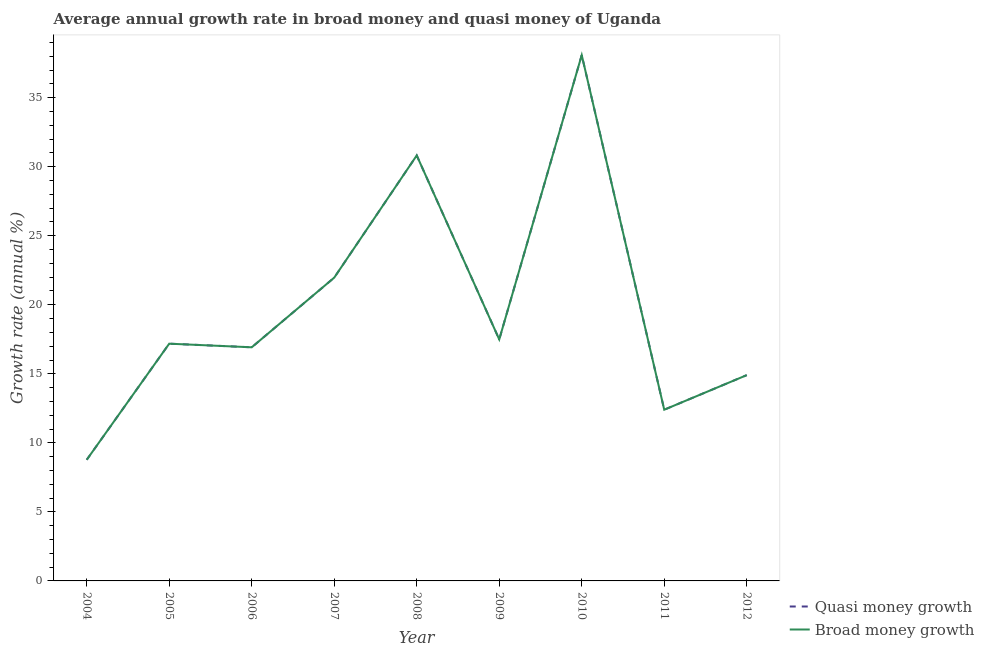How many different coloured lines are there?
Provide a short and direct response. 2. Is the number of lines equal to the number of legend labels?
Your response must be concise. Yes. What is the annual growth rate in quasi money in 2011?
Offer a very short reply. 12.4. Across all years, what is the maximum annual growth rate in broad money?
Give a very brief answer. 38.08. Across all years, what is the minimum annual growth rate in broad money?
Provide a succinct answer. 8.77. In which year was the annual growth rate in quasi money minimum?
Keep it short and to the point. 2004. What is the total annual growth rate in quasi money in the graph?
Keep it short and to the point. 178.54. What is the difference between the annual growth rate in broad money in 2005 and that in 2012?
Provide a short and direct response. 2.28. What is the difference between the annual growth rate in broad money in 2012 and the annual growth rate in quasi money in 2005?
Offer a very short reply. -2.28. What is the average annual growth rate in broad money per year?
Offer a terse response. 19.84. In the year 2007, what is the difference between the annual growth rate in broad money and annual growth rate in quasi money?
Offer a very short reply. 0. What is the ratio of the annual growth rate in broad money in 2006 to that in 2009?
Ensure brevity in your answer.  0.97. What is the difference between the highest and the second highest annual growth rate in broad money?
Your answer should be compact. 7.27. What is the difference between the highest and the lowest annual growth rate in quasi money?
Your answer should be very brief. 29.31. What is the difference between two consecutive major ticks on the Y-axis?
Ensure brevity in your answer.  5. Are the values on the major ticks of Y-axis written in scientific E-notation?
Provide a short and direct response. No. Does the graph contain grids?
Offer a very short reply. No. How many legend labels are there?
Offer a terse response. 2. What is the title of the graph?
Your response must be concise. Average annual growth rate in broad money and quasi money of Uganda. What is the label or title of the X-axis?
Offer a very short reply. Year. What is the label or title of the Y-axis?
Offer a terse response. Growth rate (annual %). What is the Growth rate (annual %) in Quasi money growth in 2004?
Offer a very short reply. 8.77. What is the Growth rate (annual %) in Broad money growth in 2004?
Your answer should be very brief. 8.77. What is the Growth rate (annual %) of Quasi money growth in 2005?
Offer a terse response. 17.18. What is the Growth rate (annual %) in Broad money growth in 2005?
Ensure brevity in your answer.  17.18. What is the Growth rate (annual %) in Quasi money growth in 2006?
Your answer should be compact. 16.92. What is the Growth rate (annual %) in Broad money growth in 2006?
Offer a very short reply. 16.92. What is the Growth rate (annual %) in Quasi money growth in 2007?
Give a very brief answer. 21.97. What is the Growth rate (annual %) in Broad money growth in 2007?
Offer a terse response. 21.97. What is the Growth rate (annual %) in Quasi money growth in 2008?
Provide a short and direct response. 30.82. What is the Growth rate (annual %) of Broad money growth in 2008?
Offer a terse response. 30.82. What is the Growth rate (annual %) in Quasi money growth in 2009?
Offer a terse response. 17.49. What is the Growth rate (annual %) of Broad money growth in 2009?
Your answer should be very brief. 17.49. What is the Growth rate (annual %) in Quasi money growth in 2010?
Ensure brevity in your answer.  38.08. What is the Growth rate (annual %) of Broad money growth in 2010?
Give a very brief answer. 38.08. What is the Growth rate (annual %) of Quasi money growth in 2011?
Provide a succinct answer. 12.4. What is the Growth rate (annual %) of Broad money growth in 2011?
Give a very brief answer. 12.4. What is the Growth rate (annual %) in Quasi money growth in 2012?
Provide a succinct answer. 14.91. What is the Growth rate (annual %) in Broad money growth in 2012?
Provide a succinct answer. 14.91. Across all years, what is the maximum Growth rate (annual %) of Quasi money growth?
Make the answer very short. 38.08. Across all years, what is the maximum Growth rate (annual %) in Broad money growth?
Provide a succinct answer. 38.08. Across all years, what is the minimum Growth rate (annual %) of Quasi money growth?
Provide a short and direct response. 8.77. Across all years, what is the minimum Growth rate (annual %) of Broad money growth?
Your answer should be very brief. 8.77. What is the total Growth rate (annual %) of Quasi money growth in the graph?
Your answer should be very brief. 178.54. What is the total Growth rate (annual %) in Broad money growth in the graph?
Provide a succinct answer. 178.54. What is the difference between the Growth rate (annual %) in Quasi money growth in 2004 and that in 2005?
Provide a short and direct response. -8.41. What is the difference between the Growth rate (annual %) of Broad money growth in 2004 and that in 2005?
Your answer should be very brief. -8.41. What is the difference between the Growth rate (annual %) in Quasi money growth in 2004 and that in 2006?
Provide a succinct answer. -8.15. What is the difference between the Growth rate (annual %) of Broad money growth in 2004 and that in 2006?
Make the answer very short. -8.15. What is the difference between the Growth rate (annual %) of Quasi money growth in 2004 and that in 2007?
Keep it short and to the point. -13.19. What is the difference between the Growth rate (annual %) of Broad money growth in 2004 and that in 2007?
Ensure brevity in your answer.  -13.19. What is the difference between the Growth rate (annual %) in Quasi money growth in 2004 and that in 2008?
Provide a short and direct response. -22.04. What is the difference between the Growth rate (annual %) in Broad money growth in 2004 and that in 2008?
Keep it short and to the point. -22.04. What is the difference between the Growth rate (annual %) of Quasi money growth in 2004 and that in 2009?
Provide a short and direct response. -8.72. What is the difference between the Growth rate (annual %) of Broad money growth in 2004 and that in 2009?
Keep it short and to the point. -8.72. What is the difference between the Growth rate (annual %) of Quasi money growth in 2004 and that in 2010?
Offer a terse response. -29.31. What is the difference between the Growth rate (annual %) of Broad money growth in 2004 and that in 2010?
Offer a very short reply. -29.31. What is the difference between the Growth rate (annual %) in Quasi money growth in 2004 and that in 2011?
Your answer should be compact. -3.63. What is the difference between the Growth rate (annual %) of Broad money growth in 2004 and that in 2011?
Your answer should be compact. -3.63. What is the difference between the Growth rate (annual %) of Quasi money growth in 2004 and that in 2012?
Offer a terse response. -6.13. What is the difference between the Growth rate (annual %) of Broad money growth in 2004 and that in 2012?
Your answer should be compact. -6.13. What is the difference between the Growth rate (annual %) in Quasi money growth in 2005 and that in 2006?
Give a very brief answer. 0.26. What is the difference between the Growth rate (annual %) of Broad money growth in 2005 and that in 2006?
Keep it short and to the point. 0.26. What is the difference between the Growth rate (annual %) of Quasi money growth in 2005 and that in 2007?
Your response must be concise. -4.78. What is the difference between the Growth rate (annual %) of Broad money growth in 2005 and that in 2007?
Provide a succinct answer. -4.78. What is the difference between the Growth rate (annual %) of Quasi money growth in 2005 and that in 2008?
Your response must be concise. -13.63. What is the difference between the Growth rate (annual %) in Broad money growth in 2005 and that in 2008?
Ensure brevity in your answer.  -13.63. What is the difference between the Growth rate (annual %) of Quasi money growth in 2005 and that in 2009?
Your answer should be compact. -0.31. What is the difference between the Growth rate (annual %) in Broad money growth in 2005 and that in 2009?
Your answer should be very brief. -0.31. What is the difference between the Growth rate (annual %) in Quasi money growth in 2005 and that in 2010?
Keep it short and to the point. -20.9. What is the difference between the Growth rate (annual %) of Broad money growth in 2005 and that in 2010?
Your response must be concise. -20.9. What is the difference between the Growth rate (annual %) in Quasi money growth in 2005 and that in 2011?
Your response must be concise. 4.78. What is the difference between the Growth rate (annual %) of Broad money growth in 2005 and that in 2011?
Your response must be concise. 4.78. What is the difference between the Growth rate (annual %) of Quasi money growth in 2005 and that in 2012?
Give a very brief answer. 2.28. What is the difference between the Growth rate (annual %) in Broad money growth in 2005 and that in 2012?
Offer a terse response. 2.28. What is the difference between the Growth rate (annual %) of Quasi money growth in 2006 and that in 2007?
Keep it short and to the point. -5.05. What is the difference between the Growth rate (annual %) of Broad money growth in 2006 and that in 2007?
Keep it short and to the point. -5.05. What is the difference between the Growth rate (annual %) in Quasi money growth in 2006 and that in 2008?
Your answer should be very brief. -13.9. What is the difference between the Growth rate (annual %) in Broad money growth in 2006 and that in 2008?
Offer a very short reply. -13.9. What is the difference between the Growth rate (annual %) in Quasi money growth in 2006 and that in 2009?
Provide a succinct answer. -0.57. What is the difference between the Growth rate (annual %) in Broad money growth in 2006 and that in 2009?
Offer a terse response. -0.57. What is the difference between the Growth rate (annual %) of Quasi money growth in 2006 and that in 2010?
Keep it short and to the point. -21.16. What is the difference between the Growth rate (annual %) of Broad money growth in 2006 and that in 2010?
Keep it short and to the point. -21.16. What is the difference between the Growth rate (annual %) of Quasi money growth in 2006 and that in 2011?
Ensure brevity in your answer.  4.52. What is the difference between the Growth rate (annual %) of Broad money growth in 2006 and that in 2011?
Ensure brevity in your answer.  4.52. What is the difference between the Growth rate (annual %) of Quasi money growth in 2006 and that in 2012?
Your answer should be very brief. 2.02. What is the difference between the Growth rate (annual %) in Broad money growth in 2006 and that in 2012?
Offer a very short reply. 2.02. What is the difference between the Growth rate (annual %) of Quasi money growth in 2007 and that in 2008?
Your answer should be very brief. -8.85. What is the difference between the Growth rate (annual %) of Broad money growth in 2007 and that in 2008?
Your answer should be very brief. -8.85. What is the difference between the Growth rate (annual %) in Quasi money growth in 2007 and that in 2009?
Keep it short and to the point. 4.48. What is the difference between the Growth rate (annual %) of Broad money growth in 2007 and that in 2009?
Your response must be concise. 4.48. What is the difference between the Growth rate (annual %) of Quasi money growth in 2007 and that in 2010?
Your answer should be compact. -16.12. What is the difference between the Growth rate (annual %) of Broad money growth in 2007 and that in 2010?
Ensure brevity in your answer.  -16.12. What is the difference between the Growth rate (annual %) in Quasi money growth in 2007 and that in 2011?
Offer a very short reply. 9.57. What is the difference between the Growth rate (annual %) of Broad money growth in 2007 and that in 2011?
Provide a succinct answer. 9.57. What is the difference between the Growth rate (annual %) of Quasi money growth in 2007 and that in 2012?
Give a very brief answer. 7.06. What is the difference between the Growth rate (annual %) in Broad money growth in 2007 and that in 2012?
Your response must be concise. 7.06. What is the difference between the Growth rate (annual %) in Quasi money growth in 2008 and that in 2009?
Make the answer very short. 13.33. What is the difference between the Growth rate (annual %) of Broad money growth in 2008 and that in 2009?
Provide a short and direct response. 13.33. What is the difference between the Growth rate (annual %) in Quasi money growth in 2008 and that in 2010?
Give a very brief answer. -7.27. What is the difference between the Growth rate (annual %) of Broad money growth in 2008 and that in 2010?
Ensure brevity in your answer.  -7.27. What is the difference between the Growth rate (annual %) in Quasi money growth in 2008 and that in 2011?
Keep it short and to the point. 18.42. What is the difference between the Growth rate (annual %) in Broad money growth in 2008 and that in 2011?
Offer a very short reply. 18.42. What is the difference between the Growth rate (annual %) of Quasi money growth in 2008 and that in 2012?
Keep it short and to the point. 15.91. What is the difference between the Growth rate (annual %) in Broad money growth in 2008 and that in 2012?
Keep it short and to the point. 15.91. What is the difference between the Growth rate (annual %) in Quasi money growth in 2009 and that in 2010?
Make the answer very short. -20.59. What is the difference between the Growth rate (annual %) in Broad money growth in 2009 and that in 2010?
Ensure brevity in your answer.  -20.59. What is the difference between the Growth rate (annual %) of Quasi money growth in 2009 and that in 2011?
Offer a terse response. 5.09. What is the difference between the Growth rate (annual %) in Broad money growth in 2009 and that in 2011?
Your answer should be very brief. 5.09. What is the difference between the Growth rate (annual %) in Quasi money growth in 2009 and that in 2012?
Keep it short and to the point. 2.58. What is the difference between the Growth rate (annual %) in Broad money growth in 2009 and that in 2012?
Your answer should be compact. 2.58. What is the difference between the Growth rate (annual %) in Quasi money growth in 2010 and that in 2011?
Provide a short and direct response. 25.68. What is the difference between the Growth rate (annual %) in Broad money growth in 2010 and that in 2011?
Give a very brief answer. 25.68. What is the difference between the Growth rate (annual %) of Quasi money growth in 2010 and that in 2012?
Your answer should be very brief. 23.18. What is the difference between the Growth rate (annual %) in Broad money growth in 2010 and that in 2012?
Provide a succinct answer. 23.18. What is the difference between the Growth rate (annual %) in Quasi money growth in 2011 and that in 2012?
Provide a short and direct response. -2.51. What is the difference between the Growth rate (annual %) of Broad money growth in 2011 and that in 2012?
Offer a terse response. -2.51. What is the difference between the Growth rate (annual %) of Quasi money growth in 2004 and the Growth rate (annual %) of Broad money growth in 2005?
Provide a succinct answer. -8.41. What is the difference between the Growth rate (annual %) of Quasi money growth in 2004 and the Growth rate (annual %) of Broad money growth in 2006?
Give a very brief answer. -8.15. What is the difference between the Growth rate (annual %) in Quasi money growth in 2004 and the Growth rate (annual %) in Broad money growth in 2007?
Offer a terse response. -13.19. What is the difference between the Growth rate (annual %) in Quasi money growth in 2004 and the Growth rate (annual %) in Broad money growth in 2008?
Your response must be concise. -22.04. What is the difference between the Growth rate (annual %) of Quasi money growth in 2004 and the Growth rate (annual %) of Broad money growth in 2009?
Provide a short and direct response. -8.72. What is the difference between the Growth rate (annual %) of Quasi money growth in 2004 and the Growth rate (annual %) of Broad money growth in 2010?
Keep it short and to the point. -29.31. What is the difference between the Growth rate (annual %) in Quasi money growth in 2004 and the Growth rate (annual %) in Broad money growth in 2011?
Make the answer very short. -3.63. What is the difference between the Growth rate (annual %) of Quasi money growth in 2004 and the Growth rate (annual %) of Broad money growth in 2012?
Provide a short and direct response. -6.13. What is the difference between the Growth rate (annual %) in Quasi money growth in 2005 and the Growth rate (annual %) in Broad money growth in 2006?
Provide a short and direct response. 0.26. What is the difference between the Growth rate (annual %) in Quasi money growth in 2005 and the Growth rate (annual %) in Broad money growth in 2007?
Your response must be concise. -4.78. What is the difference between the Growth rate (annual %) of Quasi money growth in 2005 and the Growth rate (annual %) of Broad money growth in 2008?
Make the answer very short. -13.63. What is the difference between the Growth rate (annual %) of Quasi money growth in 2005 and the Growth rate (annual %) of Broad money growth in 2009?
Provide a short and direct response. -0.31. What is the difference between the Growth rate (annual %) of Quasi money growth in 2005 and the Growth rate (annual %) of Broad money growth in 2010?
Keep it short and to the point. -20.9. What is the difference between the Growth rate (annual %) in Quasi money growth in 2005 and the Growth rate (annual %) in Broad money growth in 2011?
Provide a succinct answer. 4.78. What is the difference between the Growth rate (annual %) in Quasi money growth in 2005 and the Growth rate (annual %) in Broad money growth in 2012?
Offer a terse response. 2.28. What is the difference between the Growth rate (annual %) of Quasi money growth in 2006 and the Growth rate (annual %) of Broad money growth in 2007?
Keep it short and to the point. -5.05. What is the difference between the Growth rate (annual %) of Quasi money growth in 2006 and the Growth rate (annual %) of Broad money growth in 2008?
Provide a short and direct response. -13.9. What is the difference between the Growth rate (annual %) of Quasi money growth in 2006 and the Growth rate (annual %) of Broad money growth in 2009?
Give a very brief answer. -0.57. What is the difference between the Growth rate (annual %) in Quasi money growth in 2006 and the Growth rate (annual %) in Broad money growth in 2010?
Give a very brief answer. -21.16. What is the difference between the Growth rate (annual %) in Quasi money growth in 2006 and the Growth rate (annual %) in Broad money growth in 2011?
Offer a very short reply. 4.52. What is the difference between the Growth rate (annual %) of Quasi money growth in 2006 and the Growth rate (annual %) of Broad money growth in 2012?
Make the answer very short. 2.02. What is the difference between the Growth rate (annual %) of Quasi money growth in 2007 and the Growth rate (annual %) of Broad money growth in 2008?
Provide a short and direct response. -8.85. What is the difference between the Growth rate (annual %) in Quasi money growth in 2007 and the Growth rate (annual %) in Broad money growth in 2009?
Your answer should be very brief. 4.48. What is the difference between the Growth rate (annual %) in Quasi money growth in 2007 and the Growth rate (annual %) in Broad money growth in 2010?
Give a very brief answer. -16.12. What is the difference between the Growth rate (annual %) in Quasi money growth in 2007 and the Growth rate (annual %) in Broad money growth in 2011?
Give a very brief answer. 9.57. What is the difference between the Growth rate (annual %) of Quasi money growth in 2007 and the Growth rate (annual %) of Broad money growth in 2012?
Offer a very short reply. 7.06. What is the difference between the Growth rate (annual %) in Quasi money growth in 2008 and the Growth rate (annual %) in Broad money growth in 2009?
Offer a terse response. 13.33. What is the difference between the Growth rate (annual %) of Quasi money growth in 2008 and the Growth rate (annual %) of Broad money growth in 2010?
Your answer should be compact. -7.27. What is the difference between the Growth rate (annual %) in Quasi money growth in 2008 and the Growth rate (annual %) in Broad money growth in 2011?
Offer a very short reply. 18.42. What is the difference between the Growth rate (annual %) in Quasi money growth in 2008 and the Growth rate (annual %) in Broad money growth in 2012?
Provide a short and direct response. 15.91. What is the difference between the Growth rate (annual %) of Quasi money growth in 2009 and the Growth rate (annual %) of Broad money growth in 2010?
Offer a very short reply. -20.59. What is the difference between the Growth rate (annual %) in Quasi money growth in 2009 and the Growth rate (annual %) in Broad money growth in 2011?
Make the answer very short. 5.09. What is the difference between the Growth rate (annual %) of Quasi money growth in 2009 and the Growth rate (annual %) of Broad money growth in 2012?
Offer a terse response. 2.58. What is the difference between the Growth rate (annual %) of Quasi money growth in 2010 and the Growth rate (annual %) of Broad money growth in 2011?
Your answer should be very brief. 25.68. What is the difference between the Growth rate (annual %) of Quasi money growth in 2010 and the Growth rate (annual %) of Broad money growth in 2012?
Your answer should be very brief. 23.18. What is the difference between the Growth rate (annual %) in Quasi money growth in 2011 and the Growth rate (annual %) in Broad money growth in 2012?
Keep it short and to the point. -2.51. What is the average Growth rate (annual %) in Quasi money growth per year?
Provide a short and direct response. 19.84. What is the average Growth rate (annual %) of Broad money growth per year?
Keep it short and to the point. 19.84. In the year 2004, what is the difference between the Growth rate (annual %) of Quasi money growth and Growth rate (annual %) of Broad money growth?
Provide a succinct answer. 0. In the year 2006, what is the difference between the Growth rate (annual %) of Quasi money growth and Growth rate (annual %) of Broad money growth?
Make the answer very short. 0. In the year 2007, what is the difference between the Growth rate (annual %) in Quasi money growth and Growth rate (annual %) in Broad money growth?
Give a very brief answer. 0. In the year 2008, what is the difference between the Growth rate (annual %) of Quasi money growth and Growth rate (annual %) of Broad money growth?
Offer a terse response. 0. In the year 2010, what is the difference between the Growth rate (annual %) of Quasi money growth and Growth rate (annual %) of Broad money growth?
Your answer should be compact. 0. What is the ratio of the Growth rate (annual %) in Quasi money growth in 2004 to that in 2005?
Provide a succinct answer. 0.51. What is the ratio of the Growth rate (annual %) in Broad money growth in 2004 to that in 2005?
Your answer should be very brief. 0.51. What is the ratio of the Growth rate (annual %) in Quasi money growth in 2004 to that in 2006?
Offer a terse response. 0.52. What is the ratio of the Growth rate (annual %) in Broad money growth in 2004 to that in 2006?
Your response must be concise. 0.52. What is the ratio of the Growth rate (annual %) in Quasi money growth in 2004 to that in 2007?
Provide a succinct answer. 0.4. What is the ratio of the Growth rate (annual %) in Broad money growth in 2004 to that in 2007?
Offer a terse response. 0.4. What is the ratio of the Growth rate (annual %) in Quasi money growth in 2004 to that in 2008?
Your response must be concise. 0.28. What is the ratio of the Growth rate (annual %) of Broad money growth in 2004 to that in 2008?
Offer a terse response. 0.28. What is the ratio of the Growth rate (annual %) in Quasi money growth in 2004 to that in 2009?
Your answer should be very brief. 0.5. What is the ratio of the Growth rate (annual %) in Broad money growth in 2004 to that in 2009?
Keep it short and to the point. 0.5. What is the ratio of the Growth rate (annual %) of Quasi money growth in 2004 to that in 2010?
Your response must be concise. 0.23. What is the ratio of the Growth rate (annual %) of Broad money growth in 2004 to that in 2010?
Ensure brevity in your answer.  0.23. What is the ratio of the Growth rate (annual %) in Quasi money growth in 2004 to that in 2011?
Provide a short and direct response. 0.71. What is the ratio of the Growth rate (annual %) in Broad money growth in 2004 to that in 2011?
Ensure brevity in your answer.  0.71. What is the ratio of the Growth rate (annual %) of Quasi money growth in 2004 to that in 2012?
Offer a very short reply. 0.59. What is the ratio of the Growth rate (annual %) of Broad money growth in 2004 to that in 2012?
Your answer should be very brief. 0.59. What is the ratio of the Growth rate (annual %) of Quasi money growth in 2005 to that in 2006?
Provide a short and direct response. 1.02. What is the ratio of the Growth rate (annual %) in Broad money growth in 2005 to that in 2006?
Offer a very short reply. 1.02. What is the ratio of the Growth rate (annual %) of Quasi money growth in 2005 to that in 2007?
Offer a terse response. 0.78. What is the ratio of the Growth rate (annual %) in Broad money growth in 2005 to that in 2007?
Offer a very short reply. 0.78. What is the ratio of the Growth rate (annual %) of Quasi money growth in 2005 to that in 2008?
Ensure brevity in your answer.  0.56. What is the ratio of the Growth rate (annual %) in Broad money growth in 2005 to that in 2008?
Give a very brief answer. 0.56. What is the ratio of the Growth rate (annual %) in Quasi money growth in 2005 to that in 2009?
Your answer should be very brief. 0.98. What is the ratio of the Growth rate (annual %) of Broad money growth in 2005 to that in 2009?
Keep it short and to the point. 0.98. What is the ratio of the Growth rate (annual %) of Quasi money growth in 2005 to that in 2010?
Your response must be concise. 0.45. What is the ratio of the Growth rate (annual %) in Broad money growth in 2005 to that in 2010?
Provide a short and direct response. 0.45. What is the ratio of the Growth rate (annual %) of Quasi money growth in 2005 to that in 2011?
Your answer should be very brief. 1.39. What is the ratio of the Growth rate (annual %) in Broad money growth in 2005 to that in 2011?
Make the answer very short. 1.39. What is the ratio of the Growth rate (annual %) in Quasi money growth in 2005 to that in 2012?
Offer a terse response. 1.15. What is the ratio of the Growth rate (annual %) in Broad money growth in 2005 to that in 2012?
Provide a succinct answer. 1.15. What is the ratio of the Growth rate (annual %) of Quasi money growth in 2006 to that in 2007?
Offer a very short reply. 0.77. What is the ratio of the Growth rate (annual %) of Broad money growth in 2006 to that in 2007?
Offer a very short reply. 0.77. What is the ratio of the Growth rate (annual %) of Quasi money growth in 2006 to that in 2008?
Provide a short and direct response. 0.55. What is the ratio of the Growth rate (annual %) of Broad money growth in 2006 to that in 2008?
Give a very brief answer. 0.55. What is the ratio of the Growth rate (annual %) of Quasi money growth in 2006 to that in 2009?
Make the answer very short. 0.97. What is the ratio of the Growth rate (annual %) in Broad money growth in 2006 to that in 2009?
Make the answer very short. 0.97. What is the ratio of the Growth rate (annual %) of Quasi money growth in 2006 to that in 2010?
Keep it short and to the point. 0.44. What is the ratio of the Growth rate (annual %) in Broad money growth in 2006 to that in 2010?
Offer a terse response. 0.44. What is the ratio of the Growth rate (annual %) in Quasi money growth in 2006 to that in 2011?
Offer a very short reply. 1.36. What is the ratio of the Growth rate (annual %) in Broad money growth in 2006 to that in 2011?
Make the answer very short. 1.36. What is the ratio of the Growth rate (annual %) of Quasi money growth in 2006 to that in 2012?
Keep it short and to the point. 1.14. What is the ratio of the Growth rate (annual %) in Broad money growth in 2006 to that in 2012?
Provide a succinct answer. 1.14. What is the ratio of the Growth rate (annual %) of Quasi money growth in 2007 to that in 2008?
Provide a short and direct response. 0.71. What is the ratio of the Growth rate (annual %) of Broad money growth in 2007 to that in 2008?
Your answer should be very brief. 0.71. What is the ratio of the Growth rate (annual %) in Quasi money growth in 2007 to that in 2009?
Make the answer very short. 1.26. What is the ratio of the Growth rate (annual %) in Broad money growth in 2007 to that in 2009?
Offer a very short reply. 1.26. What is the ratio of the Growth rate (annual %) in Quasi money growth in 2007 to that in 2010?
Your response must be concise. 0.58. What is the ratio of the Growth rate (annual %) of Broad money growth in 2007 to that in 2010?
Provide a short and direct response. 0.58. What is the ratio of the Growth rate (annual %) in Quasi money growth in 2007 to that in 2011?
Make the answer very short. 1.77. What is the ratio of the Growth rate (annual %) in Broad money growth in 2007 to that in 2011?
Give a very brief answer. 1.77. What is the ratio of the Growth rate (annual %) in Quasi money growth in 2007 to that in 2012?
Provide a short and direct response. 1.47. What is the ratio of the Growth rate (annual %) in Broad money growth in 2007 to that in 2012?
Keep it short and to the point. 1.47. What is the ratio of the Growth rate (annual %) in Quasi money growth in 2008 to that in 2009?
Give a very brief answer. 1.76. What is the ratio of the Growth rate (annual %) in Broad money growth in 2008 to that in 2009?
Provide a succinct answer. 1.76. What is the ratio of the Growth rate (annual %) of Quasi money growth in 2008 to that in 2010?
Give a very brief answer. 0.81. What is the ratio of the Growth rate (annual %) in Broad money growth in 2008 to that in 2010?
Give a very brief answer. 0.81. What is the ratio of the Growth rate (annual %) of Quasi money growth in 2008 to that in 2011?
Your response must be concise. 2.49. What is the ratio of the Growth rate (annual %) in Broad money growth in 2008 to that in 2011?
Offer a terse response. 2.49. What is the ratio of the Growth rate (annual %) in Quasi money growth in 2008 to that in 2012?
Give a very brief answer. 2.07. What is the ratio of the Growth rate (annual %) in Broad money growth in 2008 to that in 2012?
Your answer should be very brief. 2.07. What is the ratio of the Growth rate (annual %) in Quasi money growth in 2009 to that in 2010?
Give a very brief answer. 0.46. What is the ratio of the Growth rate (annual %) in Broad money growth in 2009 to that in 2010?
Offer a terse response. 0.46. What is the ratio of the Growth rate (annual %) of Quasi money growth in 2009 to that in 2011?
Keep it short and to the point. 1.41. What is the ratio of the Growth rate (annual %) of Broad money growth in 2009 to that in 2011?
Your response must be concise. 1.41. What is the ratio of the Growth rate (annual %) in Quasi money growth in 2009 to that in 2012?
Give a very brief answer. 1.17. What is the ratio of the Growth rate (annual %) in Broad money growth in 2009 to that in 2012?
Give a very brief answer. 1.17. What is the ratio of the Growth rate (annual %) of Quasi money growth in 2010 to that in 2011?
Provide a succinct answer. 3.07. What is the ratio of the Growth rate (annual %) of Broad money growth in 2010 to that in 2011?
Provide a succinct answer. 3.07. What is the ratio of the Growth rate (annual %) in Quasi money growth in 2010 to that in 2012?
Offer a terse response. 2.55. What is the ratio of the Growth rate (annual %) in Broad money growth in 2010 to that in 2012?
Your answer should be very brief. 2.55. What is the ratio of the Growth rate (annual %) in Quasi money growth in 2011 to that in 2012?
Give a very brief answer. 0.83. What is the ratio of the Growth rate (annual %) of Broad money growth in 2011 to that in 2012?
Offer a terse response. 0.83. What is the difference between the highest and the second highest Growth rate (annual %) in Quasi money growth?
Your answer should be very brief. 7.27. What is the difference between the highest and the second highest Growth rate (annual %) in Broad money growth?
Offer a terse response. 7.27. What is the difference between the highest and the lowest Growth rate (annual %) in Quasi money growth?
Provide a succinct answer. 29.31. What is the difference between the highest and the lowest Growth rate (annual %) in Broad money growth?
Ensure brevity in your answer.  29.31. 